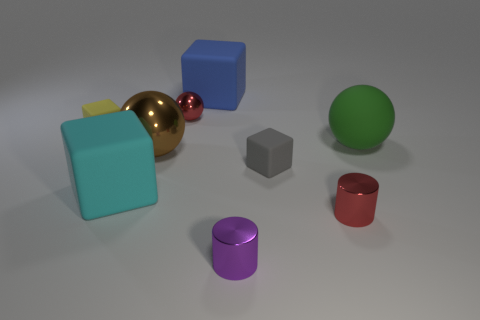Add 1 tiny rubber things. How many objects exist? 10 Subtract all cylinders. How many objects are left? 7 Add 6 tiny gray matte things. How many tiny gray matte things exist? 7 Subtract 1 green balls. How many objects are left? 8 Subtract all purple metal cylinders. Subtract all small red cylinders. How many objects are left? 7 Add 3 purple objects. How many purple objects are left? 4 